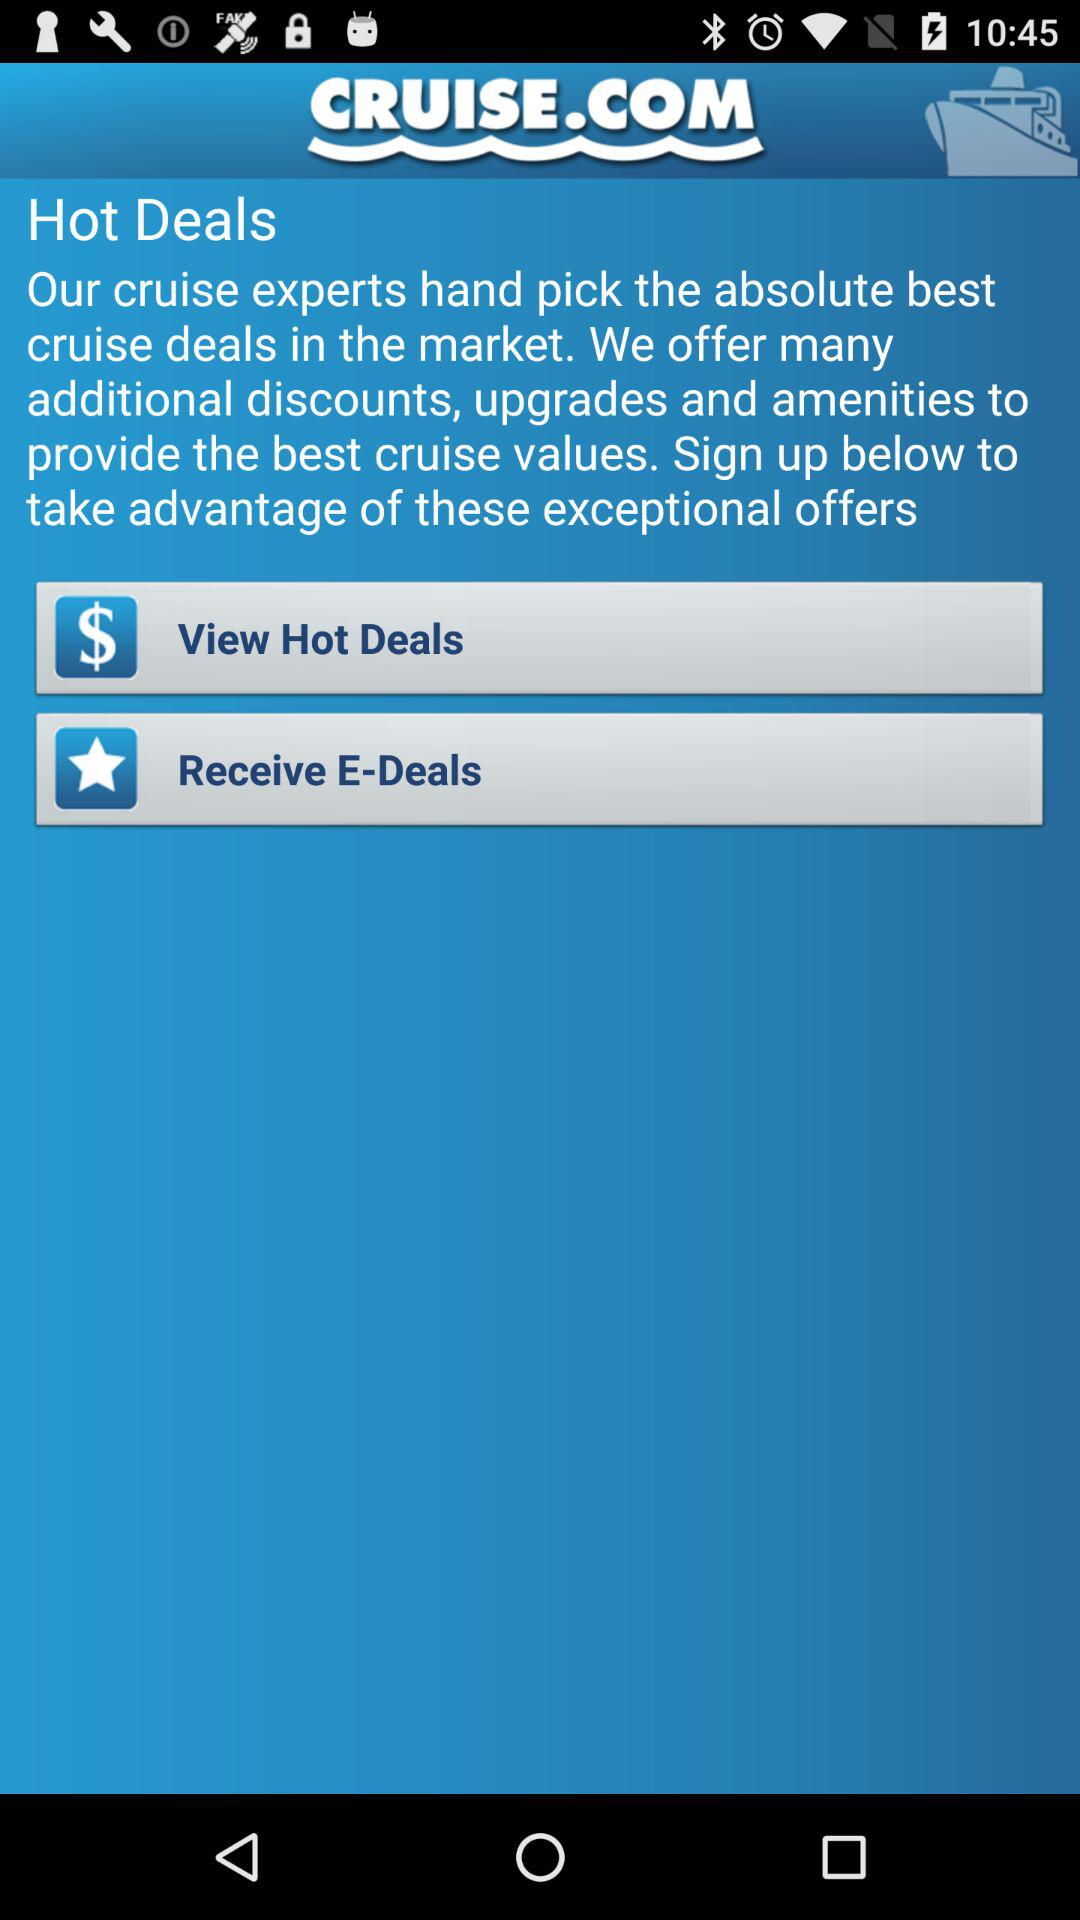What is the application name? The application name is "CRUISE.COM". 